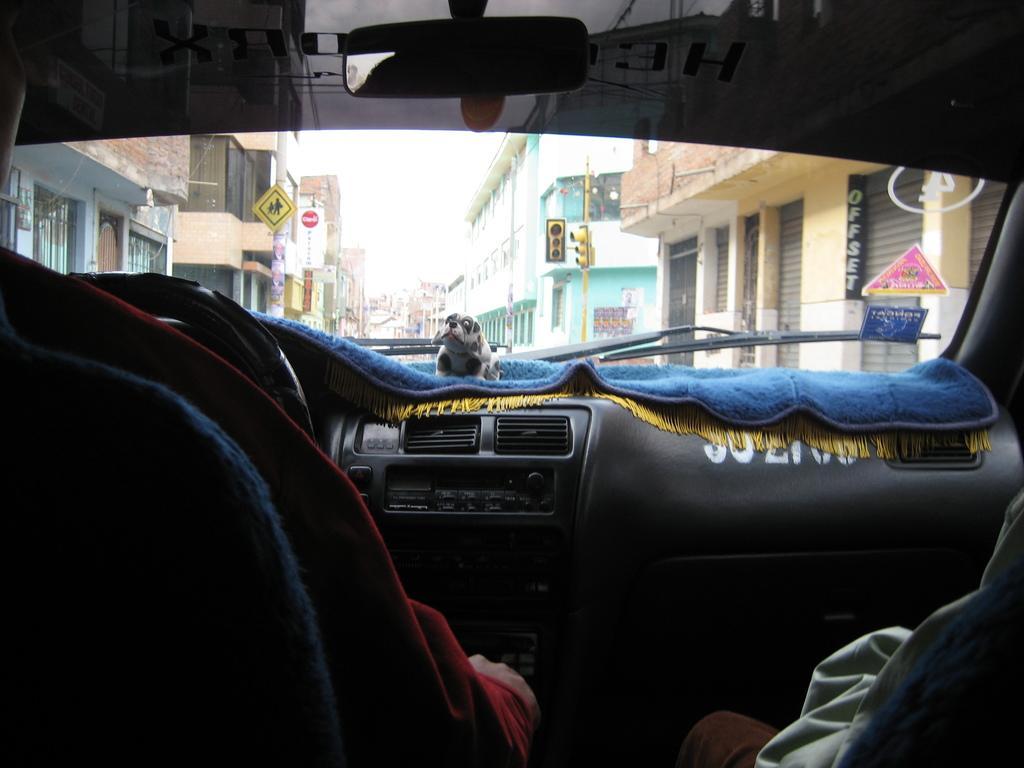Please provide a concise description of this image. This picture is taken inside the car, we can see a person driving the car, at the right side there is a person sitting, in the background we can see some buildings. 